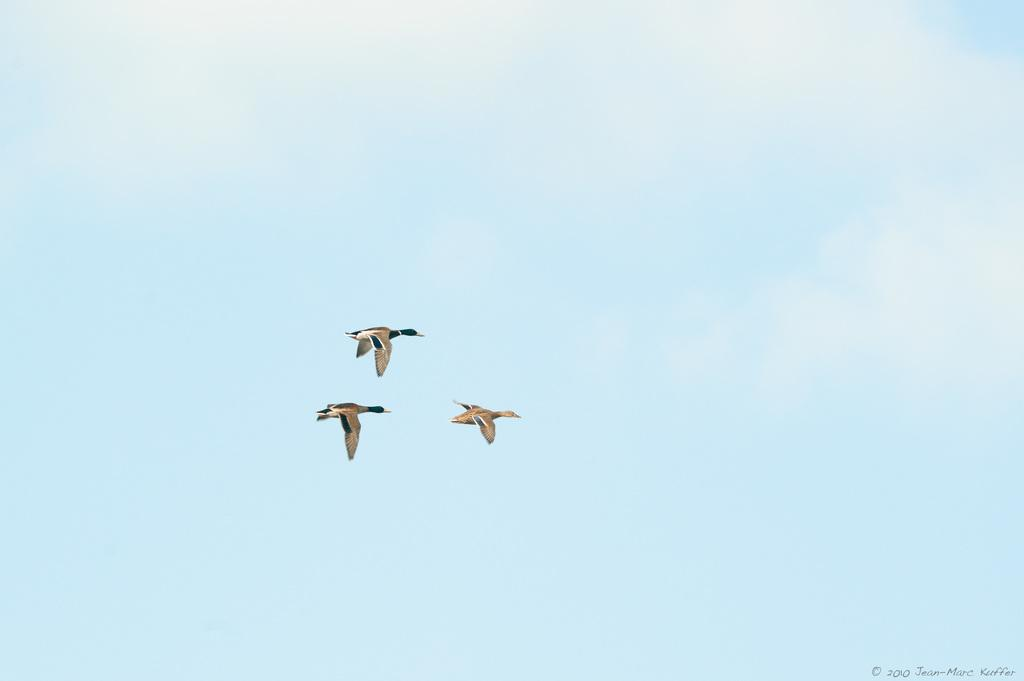What type of animals can be seen in the image? Birds can be seen in the image. Where are the birds located in the image? The birds are on the left side of the image. What part of the image do the birds occupy? The birds are in the sky. What direction is the grandfather's tail pointing in the image? There is no grandfather or tail present in the image, as it features birds in the sky. 